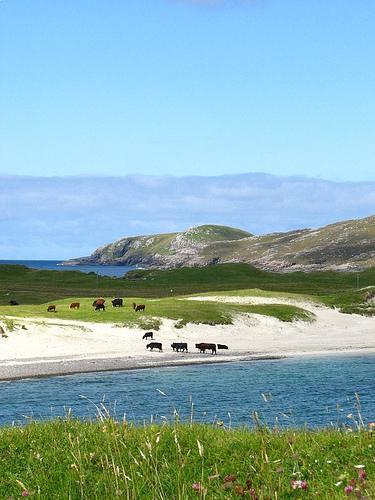How would they transport the cattle to the nearest patch of grass?
Answer the question by selecting the correct answer among the 4 following choices.
Options: Rope, boat, buoys, swim. Boat. 